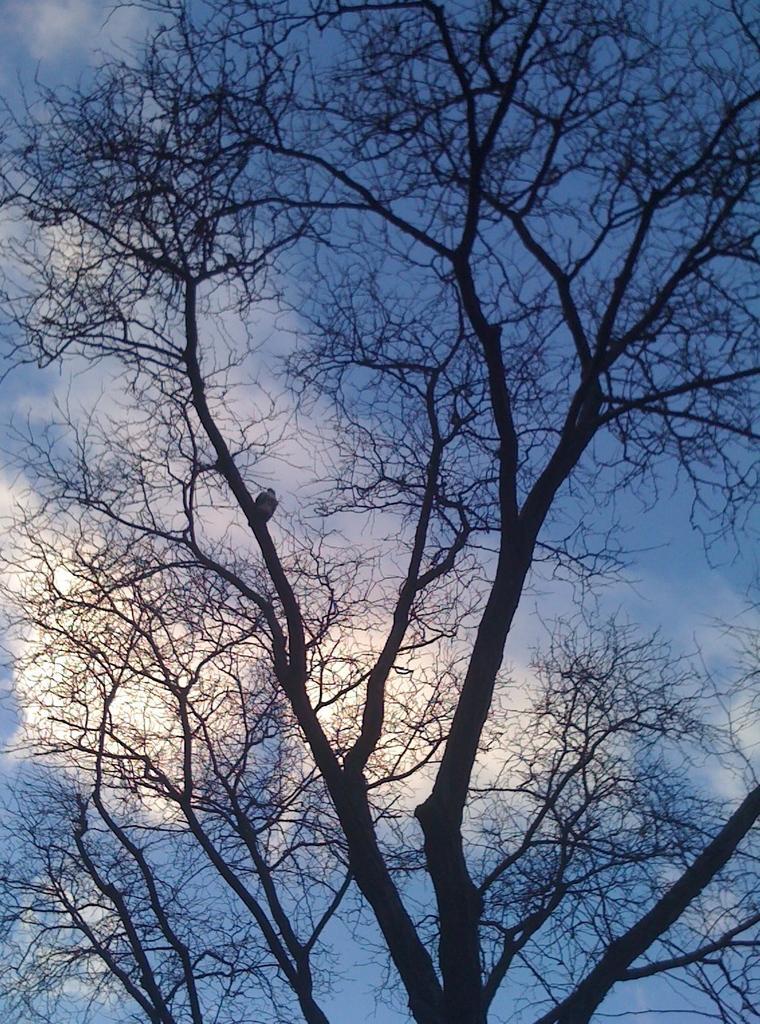Could you give a brief overview of what you see in this image? In this image we can see a tree. We can also see a bird on the branch of a tree and the sky which looks cloudy. 